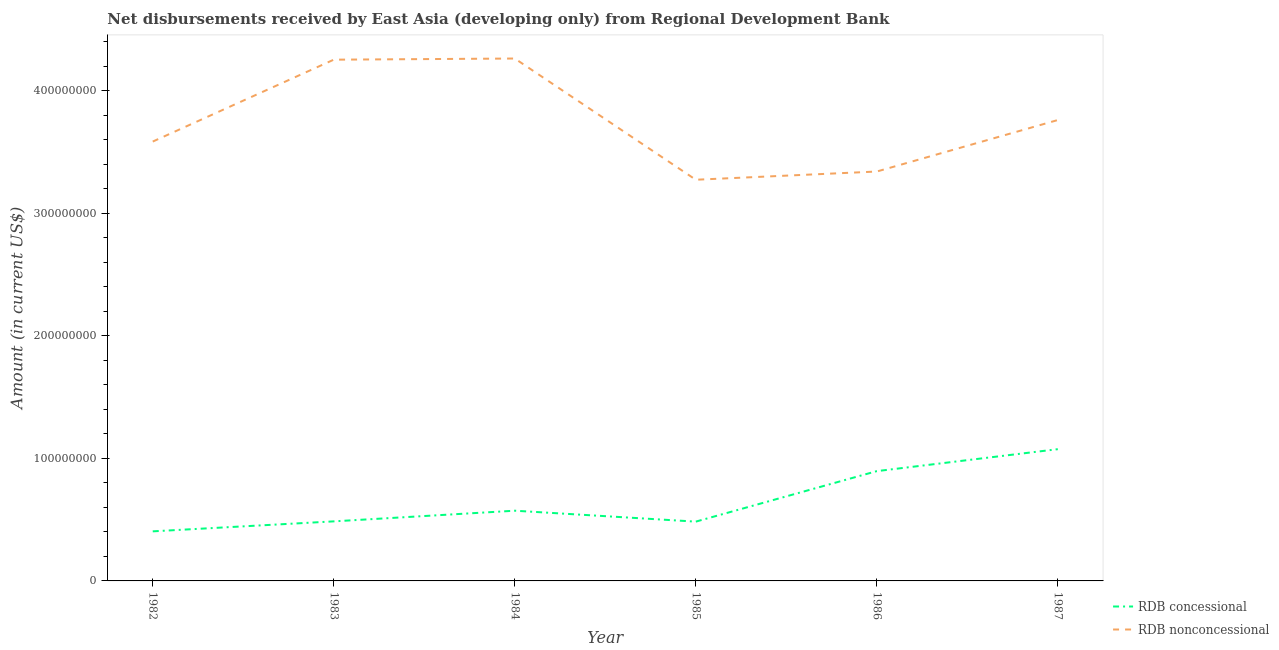How many different coloured lines are there?
Your response must be concise. 2. Is the number of lines equal to the number of legend labels?
Give a very brief answer. Yes. What is the net non concessional disbursements from rdb in 1987?
Offer a very short reply. 3.76e+08. Across all years, what is the maximum net non concessional disbursements from rdb?
Provide a short and direct response. 4.26e+08. Across all years, what is the minimum net non concessional disbursements from rdb?
Ensure brevity in your answer.  3.27e+08. What is the total net non concessional disbursements from rdb in the graph?
Give a very brief answer. 2.25e+09. What is the difference between the net non concessional disbursements from rdb in 1982 and that in 1985?
Your response must be concise. 3.12e+07. What is the difference between the net non concessional disbursements from rdb in 1987 and the net concessional disbursements from rdb in 1985?
Your answer should be compact. 3.28e+08. What is the average net concessional disbursements from rdb per year?
Your answer should be very brief. 6.53e+07. In the year 1983, what is the difference between the net concessional disbursements from rdb and net non concessional disbursements from rdb?
Make the answer very short. -3.77e+08. In how many years, is the net concessional disbursements from rdb greater than 380000000 US$?
Offer a terse response. 0. What is the ratio of the net concessional disbursements from rdb in 1984 to that in 1985?
Provide a short and direct response. 1.18. What is the difference between the highest and the second highest net concessional disbursements from rdb?
Keep it short and to the point. 1.79e+07. What is the difference between the highest and the lowest net concessional disbursements from rdb?
Give a very brief answer. 6.71e+07. In how many years, is the net concessional disbursements from rdb greater than the average net concessional disbursements from rdb taken over all years?
Give a very brief answer. 2. Is the sum of the net non concessional disbursements from rdb in 1982 and 1987 greater than the maximum net concessional disbursements from rdb across all years?
Make the answer very short. Yes. Does the net non concessional disbursements from rdb monotonically increase over the years?
Provide a succinct answer. No. Is the net concessional disbursements from rdb strictly greater than the net non concessional disbursements from rdb over the years?
Keep it short and to the point. No. How many years are there in the graph?
Give a very brief answer. 6. What is the difference between two consecutive major ticks on the Y-axis?
Ensure brevity in your answer.  1.00e+08. Are the values on the major ticks of Y-axis written in scientific E-notation?
Offer a very short reply. No. Where does the legend appear in the graph?
Your answer should be compact. Bottom right. How many legend labels are there?
Make the answer very short. 2. How are the legend labels stacked?
Your response must be concise. Vertical. What is the title of the graph?
Make the answer very short. Net disbursements received by East Asia (developing only) from Regional Development Bank. What is the label or title of the X-axis?
Your answer should be compact. Year. What is the label or title of the Y-axis?
Offer a terse response. Amount (in current US$). What is the Amount (in current US$) in RDB concessional in 1982?
Make the answer very short. 4.05e+07. What is the Amount (in current US$) of RDB nonconcessional in 1982?
Give a very brief answer. 3.59e+08. What is the Amount (in current US$) of RDB concessional in 1983?
Provide a short and direct response. 4.86e+07. What is the Amount (in current US$) of RDB nonconcessional in 1983?
Provide a succinct answer. 4.25e+08. What is the Amount (in current US$) in RDB concessional in 1984?
Give a very brief answer. 5.73e+07. What is the Amount (in current US$) in RDB nonconcessional in 1984?
Provide a short and direct response. 4.26e+08. What is the Amount (in current US$) in RDB concessional in 1985?
Ensure brevity in your answer.  4.84e+07. What is the Amount (in current US$) in RDB nonconcessional in 1985?
Make the answer very short. 3.27e+08. What is the Amount (in current US$) in RDB concessional in 1986?
Your answer should be very brief. 8.96e+07. What is the Amount (in current US$) in RDB nonconcessional in 1986?
Provide a short and direct response. 3.34e+08. What is the Amount (in current US$) in RDB concessional in 1987?
Your answer should be very brief. 1.08e+08. What is the Amount (in current US$) of RDB nonconcessional in 1987?
Provide a succinct answer. 3.76e+08. Across all years, what is the maximum Amount (in current US$) in RDB concessional?
Your response must be concise. 1.08e+08. Across all years, what is the maximum Amount (in current US$) of RDB nonconcessional?
Make the answer very short. 4.26e+08. Across all years, what is the minimum Amount (in current US$) of RDB concessional?
Keep it short and to the point. 4.05e+07. Across all years, what is the minimum Amount (in current US$) in RDB nonconcessional?
Offer a very short reply. 3.27e+08. What is the total Amount (in current US$) of RDB concessional in the graph?
Offer a very short reply. 3.92e+08. What is the total Amount (in current US$) of RDB nonconcessional in the graph?
Keep it short and to the point. 2.25e+09. What is the difference between the Amount (in current US$) of RDB concessional in 1982 and that in 1983?
Keep it short and to the point. -8.14e+06. What is the difference between the Amount (in current US$) of RDB nonconcessional in 1982 and that in 1983?
Keep it short and to the point. -6.68e+07. What is the difference between the Amount (in current US$) in RDB concessional in 1982 and that in 1984?
Offer a terse response. -1.68e+07. What is the difference between the Amount (in current US$) of RDB nonconcessional in 1982 and that in 1984?
Offer a terse response. -6.78e+07. What is the difference between the Amount (in current US$) of RDB concessional in 1982 and that in 1985?
Make the answer very short. -7.92e+06. What is the difference between the Amount (in current US$) in RDB nonconcessional in 1982 and that in 1985?
Your answer should be compact. 3.12e+07. What is the difference between the Amount (in current US$) of RDB concessional in 1982 and that in 1986?
Offer a terse response. -4.91e+07. What is the difference between the Amount (in current US$) in RDB nonconcessional in 1982 and that in 1986?
Offer a very short reply. 2.44e+07. What is the difference between the Amount (in current US$) of RDB concessional in 1982 and that in 1987?
Keep it short and to the point. -6.71e+07. What is the difference between the Amount (in current US$) in RDB nonconcessional in 1982 and that in 1987?
Offer a very short reply. -1.76e+07. What is the difference between the Amount (in current US$) in RDB concessional in 1983 and that in 1984?
Offer a terse response. -8.71e+06. What is the difference between the Amount (in current US$) in RDB nonconcessional in 1983 and that in 1984?
Offer a terse response. -9.45e+05. What is the difference between the Amount (in current US$) of RDB concessional in 1983 and that in 1985?
Your response must be concise. 2.18e+05. What is the difference between the Amount (in current US$) in RDB nonconcessional in 1983 and that in 1985?
Offer a terse response. 9.80e+07. What is the difference between the Amount (in current US$) in RDB concessional in 1983 and that in 1986?
Give a very brief answer. -4.10e+07. What is the difference between the Amount (in current US$) in RDB nonconcessional in 1983 and that in 1986?
Provide a short and direct response. 9.13e+07. What is the difference between the Amount (in current US$) of RDB concessional in 1983 and that in 1987?
Keep it short and to the point. -5.89e+07. What is the difference between the Amount (in current US$) in RDB nonconcessional in 1983 and that in 1987?
Make the answer very short. 4.93e+07. What is the difference between the Amount (in current US$) in RDB concessional in 1984 and that in 1985?
Keep it short and to the point. 8.92e+06. What is the difference between the Amount (in current US$) in RDB nonconcessional in 1984 and that in 1985?
Provide a succinct answer. 9.89e+07. What is the difference between the Amount (in current US$) in RDB concessional in 1984 and that in 1986?
Your answer should be compact. -3.23e+07. What is the difference between the Amount (in current US$) of RDB nonconcessional in 1984 and that in 1986?
Your answer should be compact. 9.22e+07. What is the difference between the Amount (in current US$) in RDB concessional in 1984 and that in 1987?
Keep it short and to the point. -5.02e+07. What is the difference between the Amount (in current US$) of RDB nonconcessional in 1984 and that in 1987?
Give a very brief answer. 5.02e+07. What is the difference between the Amount (in current US$) of RDB concessional in 1985 and that in 1986?
Your answer should be very brief. -4.12e+07. What is the difference between the Amount (in current US$) of RDB nonconcessional in 1985 and that in 1986?
Your response must be concise. -6.71e+06. What is the difference between the Amount (in current US$) in RDB concessional in 1985 and that in 1987?
Give a very brief answer. -5.91e+07. What is the difference between the Amount (in current US$) in RDB nonconcessional in 1985 and that in 1987?
Offer a terse response. -4.87e+07. What is the difference between the Amount (in current US$) of RDB concessional in 1986 and that in 1987?
Offer a very short reply. -1.79e+07. What is the difference between the Amount (in current US$) in RDB nonconcessional in 1986 and that in 1987?
Offer a terse response. -4.20e+07. What is the difference between the Amount (in current US$) of RDB concessional in 1982 and the Amount (in current US$) of RDB nonconcessional in 1983?
Your response must be concise. -3.85e+08. What is the difference between the Amount (in current US$) in RDB concessional in 1982 and the Amount (in current US$) in RDB nonconcessional in 1984?
Your answer should be compact. -3.86e+08. What is the difference between the Amount (in current US$) of RDB concessional in 1982 and the Amount (in current US$) of RDB nonconcessional in 1985?
Your response must be concise. -2.87e+08. What is the difference between the Amount (in current US$) in RDB concessional in 1982 and the Amount (in current US$) in RDB nonconcessional in 1986?
Provide a short and direct response. -2.94e+08. What is the difference between the Amount (in current US$) of RDB concessional in 1982 and the Amount (in current US$) of RDB nonconcessional in 1987?
Offer a terse response. -3.36e+08. What is the difference between the Amount (in current US$) of RDB concessional in 1983 and the Amount (in current US$) of RDB nonconcessional in 1984?
Provide a short and direct response. -3.78e+08. What is the difference between the Amount (in current US$) in RDB concessional in 1983 and the Amount (in current US$) in RDB nonconcessional in 1985?
Offer a very short reply. -2.79e+08. What is the difference between the Amount (in current US$) of RDB concessional in 1983 and the Amount (in current US$) of RDB nonconcessional in 1986?
Make the answer very short. -2.86e+08. What is the difference between the Amount (in current US$) of RDB concessional in 1983 and the Amount (in current US$) of RDB nonconcessional in 1987?
Provide a short and direct response. -3.28e+08. What is the difference between the Amount (in current US$) of RDB concessional in 1984 and the Amount (in current US$) of RDB nonconcessional in 1985?
Keep it short and to the point. -2.70e+08. What is the difference between the Amount (in current US$) in RDB concessional in 1984 and the Amount (in current US$) in RDB nonconcessional in 1986?
Give a very brief answer. -2.77e+08. What is the difference between the Amount (in current US$) of RDB concessional in 1984 and the Amount (in current US$) of RDB nonconcessional in 1987?
Offer a very short reply. -3.19e+08. What is the difference between the Amount (in current US$) of RDB concessional in 1985 and the Amount (in current US$) of RDB nonconcessional in 1986?
Your answer should be very brief. -2.86e+08. What is the difference between the Amount (in current US$) of RDB concessional in 1985 and the Amount (in current US$) of RDB nonconcessional in 1987?
Provide a succinct answer. -3.28e+08. What is the difference between the Amount (in current US$) of RDB concessional in 1986 and the Amount (in current US$) of RDB nonconcessional in 1987?
Offer a very short reply. -2.87e+08. What is the average Amount (in current US$) of RDB concessional per year?
Keep it short and to the point. 6.53e+07. What is the average Amount (in current US$) in RDB nonconcessional per year?
Offer a terse response. 3.75e+08. In the year 1982, what is the difference between the Amount (in current US$) of RDB concessional and Amount (in current US$) of RDB nonconcessional?
Provide a succinct answer. -3.18e+08. In the year 1983, what is the difference between the Amount (in current US$) of RDB concessional and Amount (in current US$) of RDB nonconcessional?
Make the answer very short. -3.77e+08. In the year 1984, what is the difference between the Amount (in current US$) in RDB concessional and Amount (in current US$) in RDB nonconcessional?
Give a very brief answer. -3.69e+08. In the year 1985, what is the difference between the Amount (in current US$) in RDB concessional and Amount (in current US$) in RDB nonconcessional?
Keep it short and to the point. -2.79e+08. In the year 1986, what is the difference between the Amount (in current US$) of RDB concessional and Amount (in current US$) of RDB nonconcessional?
Ensure brevity in your answer.  -2.45e+08. In the year 1987, what is the difference between the Amount (in current US$) of RDB concessional and Amount (in current US$) of RDB nonconcessional?
Your answer should be very brief. -2.69e+08. What is the ratio of the Amount (in current US$) in RDB concessional in 1982 to that in 1983?
Your response must be concise. 0.83. What is the ratio of the Amount (in current US$) in RDB nonconcessional in 1982 to that in 1983?
Offer a very short reply. 0.84. What is the ratio of the Amount (in current US$) in RDB concessional in 1982 to that in 1984?
Give a very brief answer. 0.71. What is the ratio of the Amount (in current US$) of RDB nonconcessional in 1982 to that in 1984?
Provide a short and direct response. 0.84. What is the ratio of the Amount (in current US$) of RDB concessional in 1982 to that in 1985?
Provide a succinct answer. 0.84. What is the ratio of the Amount (in current US$) of RDB nonconcessional in 1982 to that in 1985?
Your response must be concise. 1.1. What is the ratio of the Amount (in current US$) in RDB concessional in 1982 to that in 1986?
Your answer should be very brief. 0.45. What is the ratio of the Amount (in current US$) in RDB nonconcessional in 1982 to that in 1986?
Offer a terse response. 1.07. What is the ratio of the Amount (in current US$) in RDB concessional in 1982 to that in 1987?
Provide a succinct answer. 0.38. What is the ratio of the Amount (in current US$) of RDB nonconcessional in 1982 to that in 1987?
Offer a very short reply. 0.95. What is the ratio of the Amount (in current US$) in RDB concessional in 1983 to that in 1984?
Your response must be concise. 0.85. What is the ratio of the Amount (in current US$) of RDB nonconcessional in 1983 to that in 1984?
Give a very brief answer. 1. What is the ratio of the Amount (in current US$) of RDB concessional in 1983 to that in 1985?
Offer a very short reply. 1. What is the ratio of the Amount (in current US$) in RDB nonconcessional in 1983 to that in 1985?
Offer a very short reply. 1.3. What is the ratio of the Amount (in current US$) in RDB concessional in 1983 to that in 1986?
Ensure brevity in your answer.  0.54. What is the ratio of the Amount (in current US$) in RDB nonconcessional in 1983 to that in 1986?
Make the answer very short. 1.27. What is the ratio of the Amount (in current US$) in RDB concessional in 1983 to that in 1987?
Offer a very short reply. 0.45. What is the ratio of the Amount (in current US$) of RDB nonconcessional in 1983 to that in 1987?
Your answer should be very brief. 1.13. What is the ratio of the Amount (in current US$) in RDB concessional in 1984 to that in 1985?
Provide a succinct answer. 1.18. What is the ratio of the Amount (in current US$) in RDB nonconcessional in 1984 to that in 1985?
Keep it short and to the point. 1.3. What is the ratio of the Amount (in current US$) of RDB concessional in 1984 to that in 1986?
Your answer should be compact. 0.64. What is the ratio of the Amount (in current US$) in RDB nonconcessional in 1984 to that in 1986?
Make the answer very short. 1.28. What is the ratio of the Amount (in current US$) of RDB concessional in 1984 to that in 1987?
Provide a succinct answer. 0.53. What is the ratio of the Amount (in current US$) in RDB nonconcessional in 1984 to that in 1987?
Provide a succinct answer. 1.13. What is the ratio of the Amount (in current US$) in RDB concessional in 1985 to that in 1986?
Your response must be concise. 0.54. What is the ratio of the Amount (in current US$) of RDB nonconcessional in 1985 to that in 1986?
Your response must be concise. 0.98. What is the ratio of the Amount (in current US$) in RDB concessional in 1985 to that in 1987?
Provide a succinct answer. 0.45. What is the ratio of the Amount (in current US$) in RDB nonconcessional in 1985 to that in 1987?
Provide a short and direct response. 0.87. What is the ratio of the Amount (in current US$) of RDB concessional in 1986 to that in 1987?
Ensure brevity in your answer.  0.83. What is the ratio of the Amount (in current US$) of RDB nonconcessional in 1986 to that in 1987?
Your answer should be very brief. 0.89. What is the difference between the highest and the second highest Amount (in current US$) in RDB concessional?
Ensure brevity in your answer.  1.79e+07. What is the difference between the highest and the second highest Amount (in current US$) in RDB nonconcessional?
Ensure brevity in your answer.  9.45e+05. What is the difference between the highest and the lowest Amount (in current US$) of RDB concessional?
Keep it short and to the point. 6.71e+07. What is the difference between the highest and the lowest Amount (in current US$) in RDB nonconcessional?
Provide a succinct answer. 9.89e+07. 